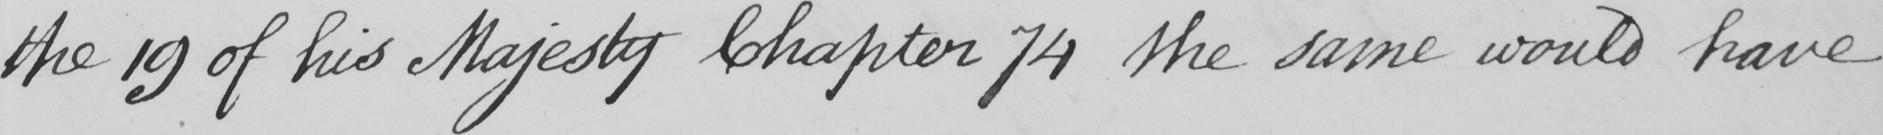Can you read and transcribe this handwriting? the 19 of his Majesty Chapter 74 the same would have 